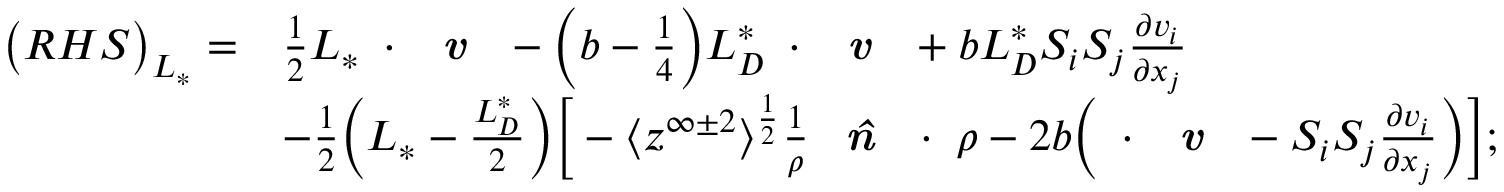Convert formula to latex. <formula><loc_0><loc_0><loc_500><loc_500>\begin{array} { r l } { \left ( R H S \right ) _ { L _ { * } } = } & { \frac { 1 } { 2 } { L _ { * } } \nabla \cdot \emph { v } - \left ( b - \frac { 1 } { 4 } \right ) { L _ { D } ^ { * } } \nabla \cdot \emph { v } + b { L _ { D } ^ { * } } S _ { i } S _ { j } \frac { \partial v _ { i } } { \partial x _ { j } } } \\ & { - \frac { 1 } { 2 } \left ( { L _ { * } } - \frac { L _ { D } ^ { * } } { 2 } \right ) \left [ - \Big < z ^ { \infty \pm 2 } \Big > ^ { \frac { 1 } { 2 } } \frac { 1 } { \rho } \emph { \hat { n } } \cdot \nabla \rho - 2 b \left ( \nabla \cdot \emph { v } - S _ { i } S _ { j } \frac { \partial v _ { i } } { \partial x _ { j } } \right ) \right ] ; } \end{array}</formula> 